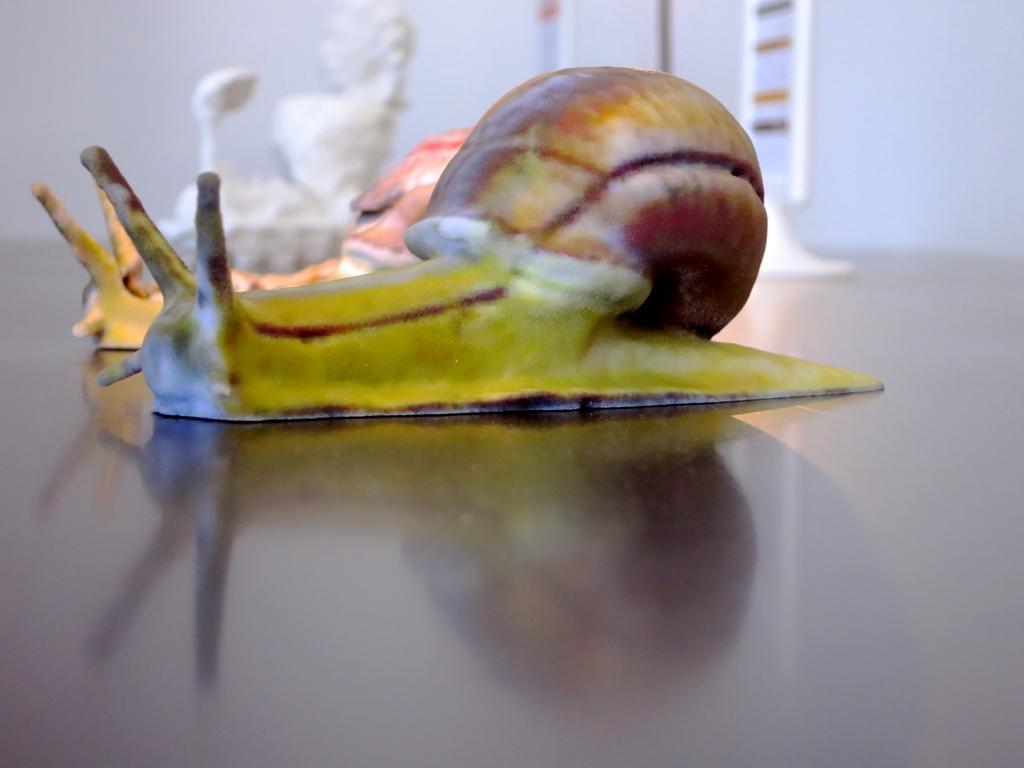How would you summarize this image in a sentence or two? In the foreground I can see two sea snails on the floor. In the background I can see a sculpture and a wall. This image is taken in a hall. 